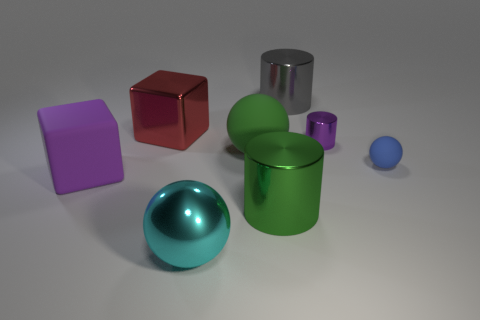Subtract all blue matte spheres. How many spheres are left? 2 Add 1 small spheres. How many objects exist? 9 Subtract 1 spheres. How many spheres are left? 2 Subtract all purple cubes. How many cubes are left? 1 Subtract all blocks. How many objects are left? 6 Subtract 0 blue cubes. How many objects are left? 8 Subtract all green cubes. Subtract all red balls. How many cubes are left? 2 Subtract all big metal cylinders. Subtract all large red things. How many objects are left? 5 Add 6 big purple blocks. How many big purple blocks are left? 7 Add 2 small shiny objects. How many small shiny objects exist? 3 